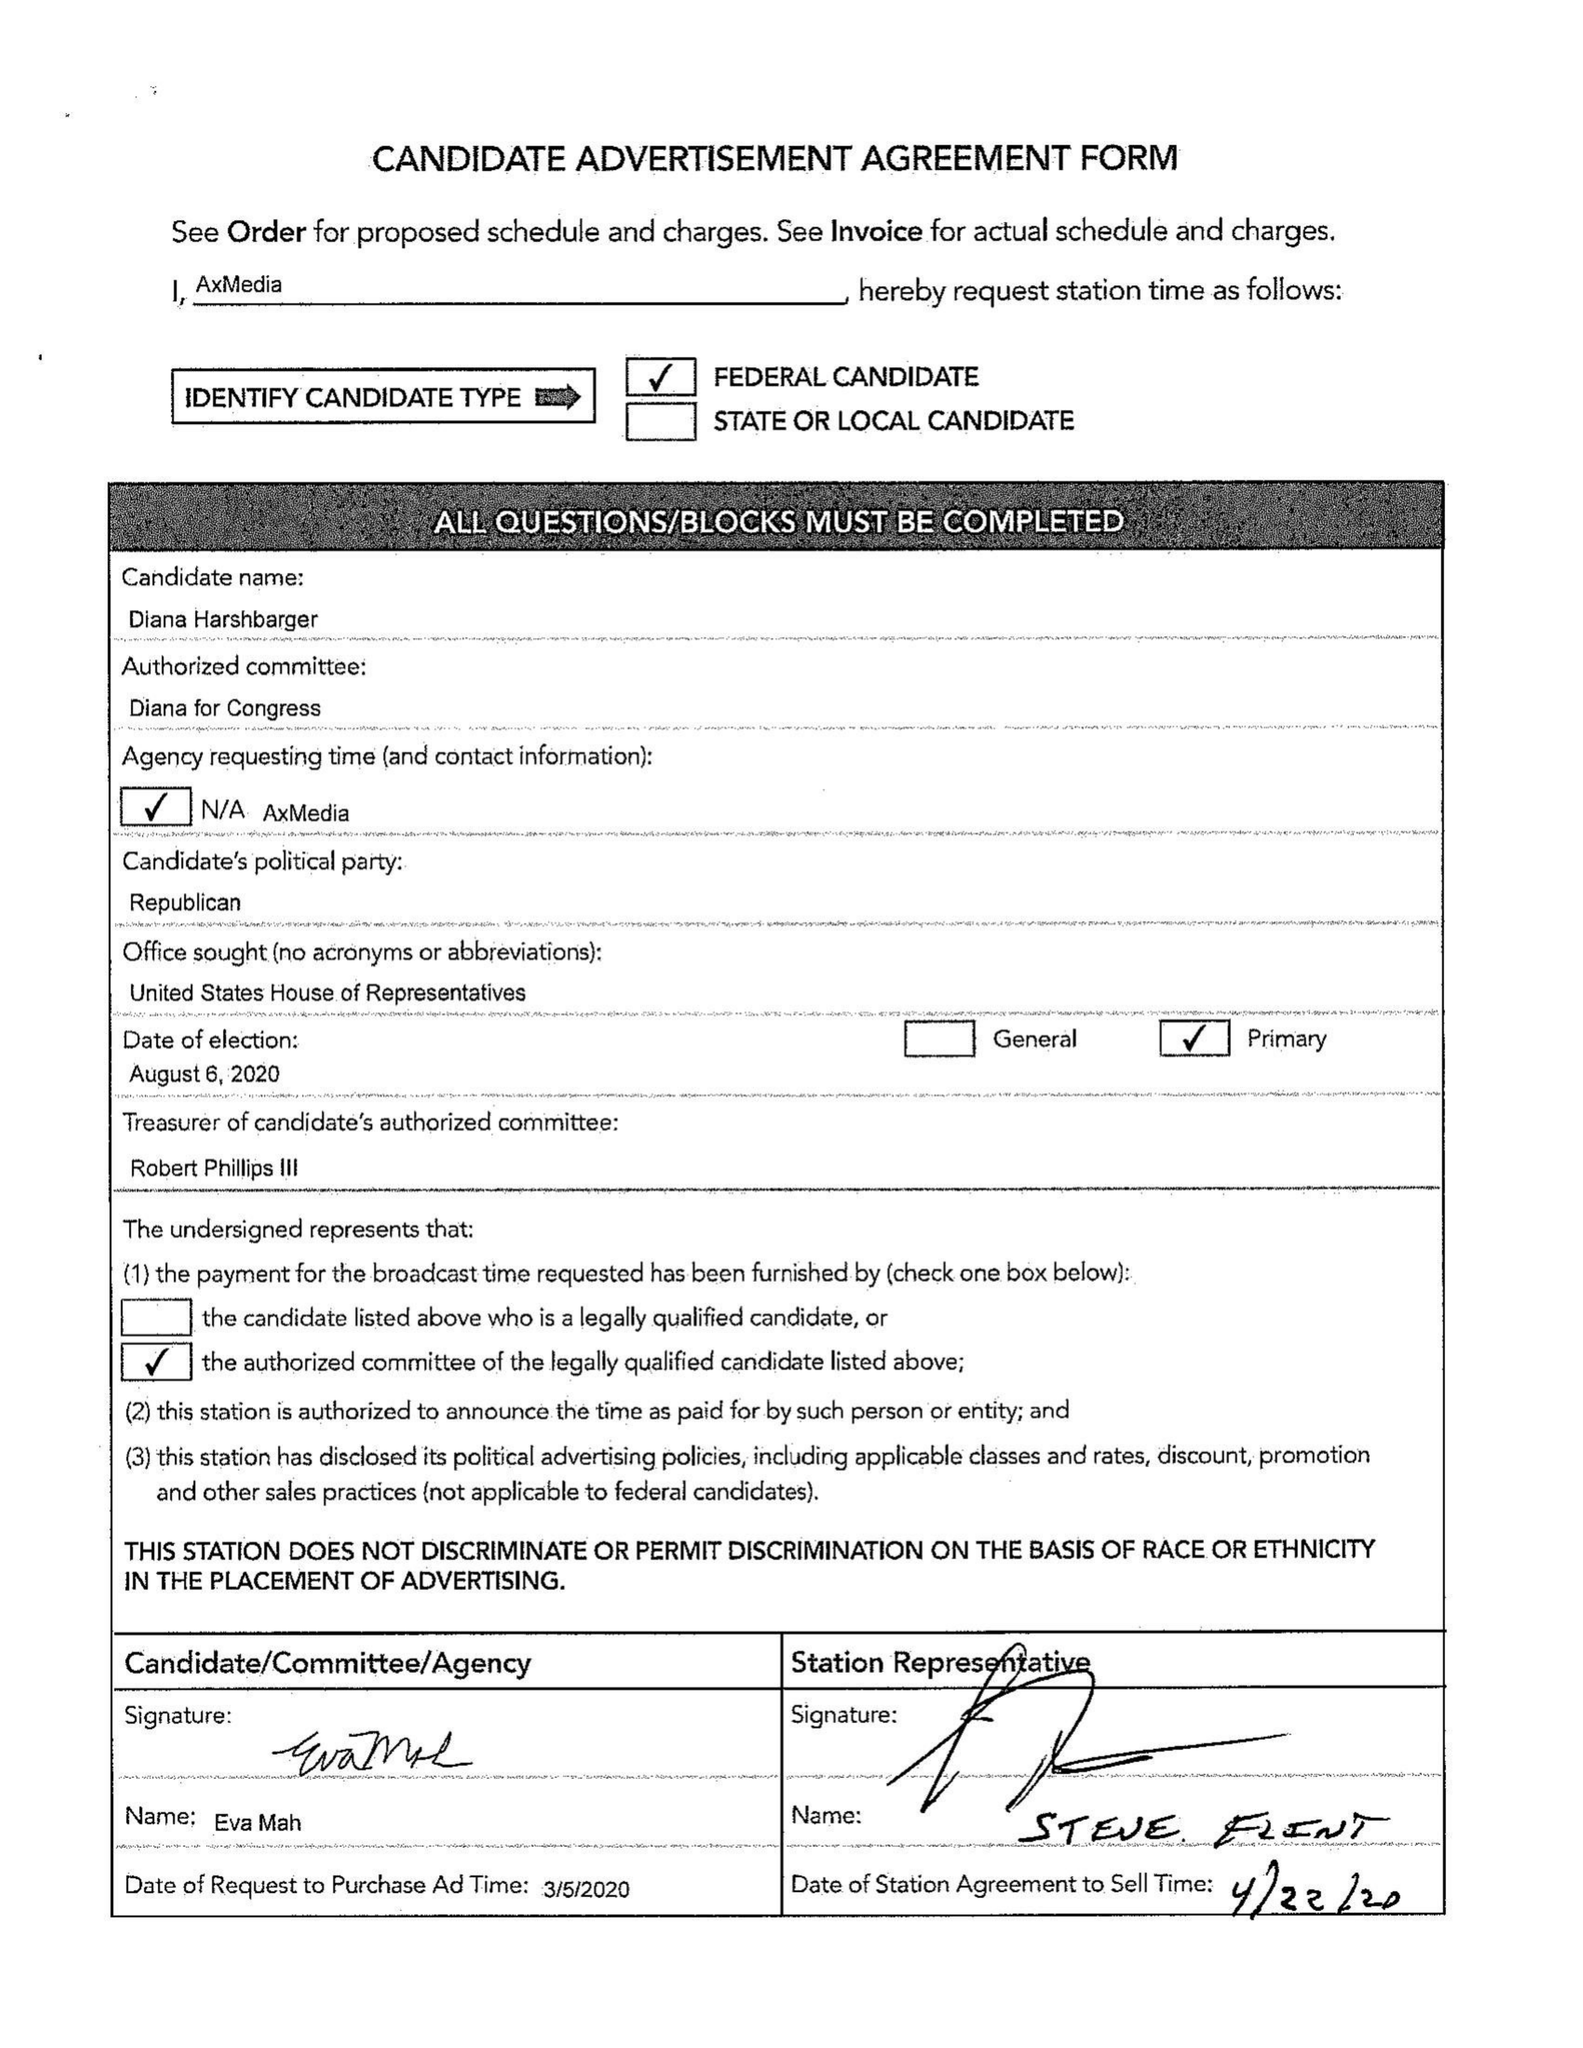What is the value for the gross_amount?
Answer the question using a single word or phrase. 18655.00 